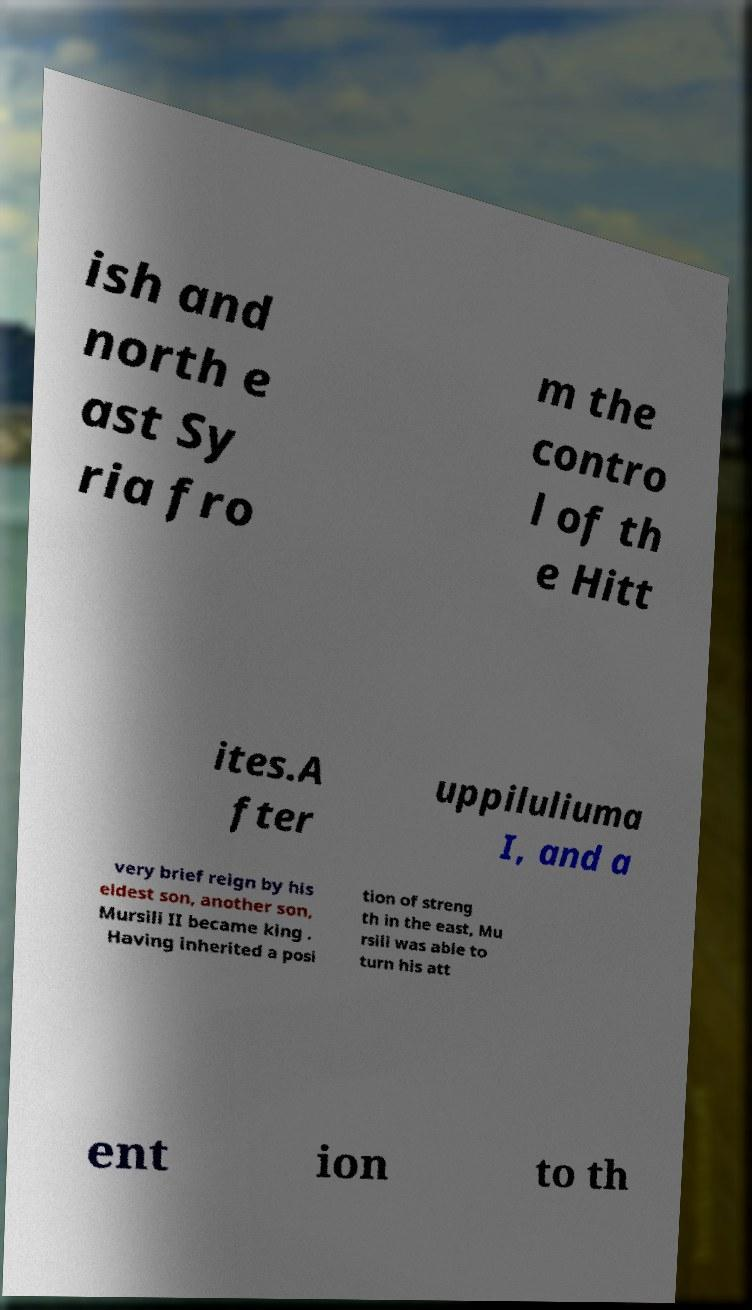Could you assist in decoding the text presented in this image and type it out clearly? ish and north e ast Sy ria fro m the contro l of th e Hitt ites.A fter uppiluliuma I, and a very brief reign by his eldest son, another son, Mursili II became king . Having inherited a posi tion of streng th in the east, Mu rsili was able to turn his att ent ion to th 